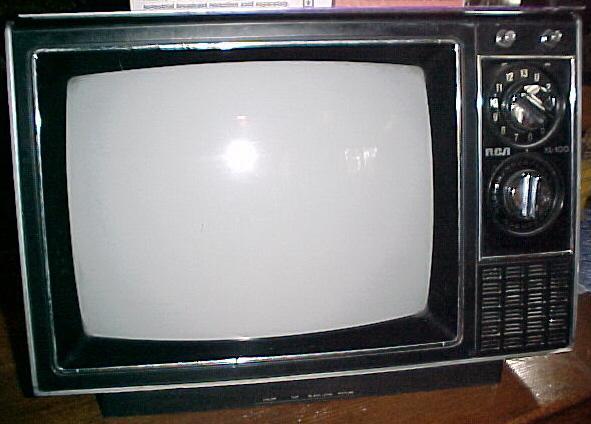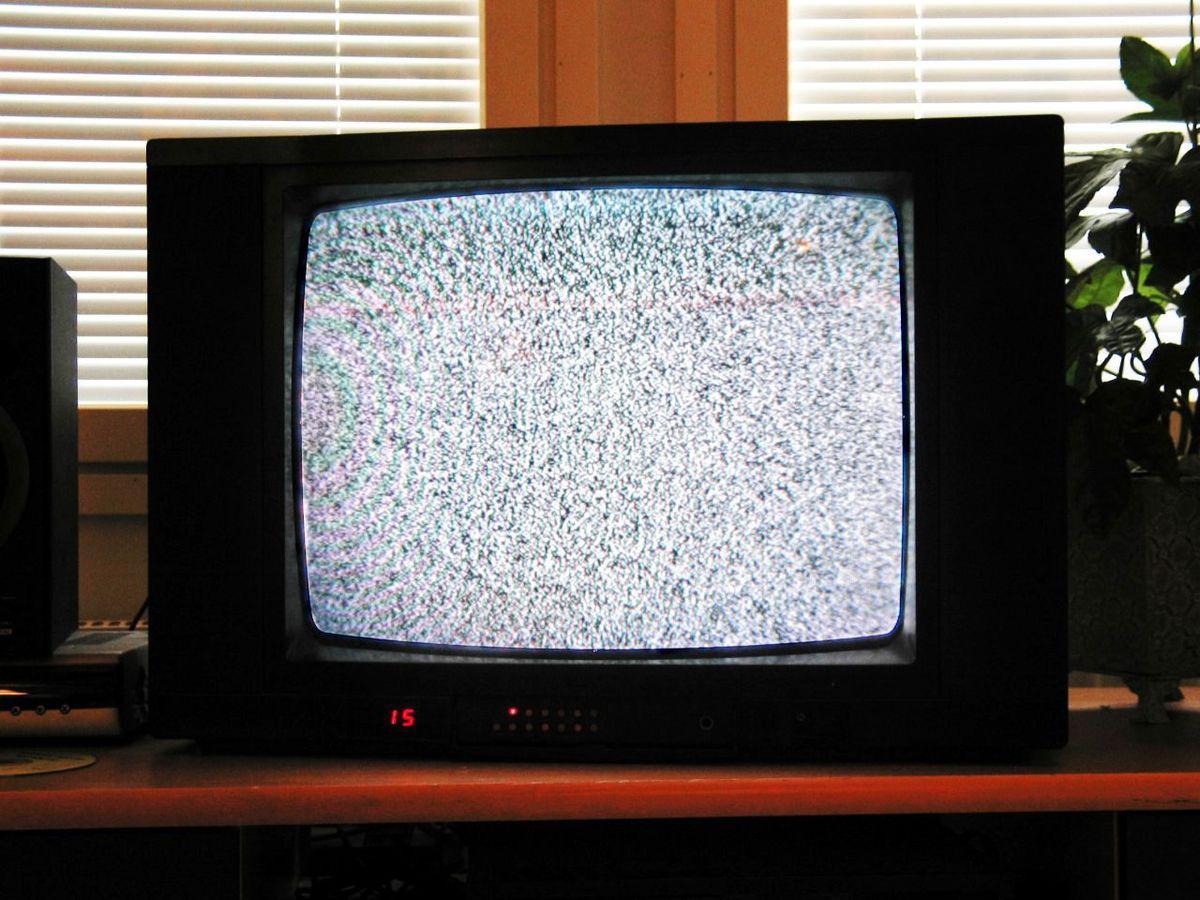The first image is the image on the left, the second image is the image on the right. Analyze the images presented: Is the assertion "Each image shows one old-fashioned TV set with grainy static """"fuzz"""" on the screen, and the right image shows a TV set on a solid-colored background." valid? Answer yes or no. No. The first image is the image on the left, the second image is the image on the right. Considering the images on both sides, is "One of the television sets includes a color image." valid? Answer yes or no. No. 